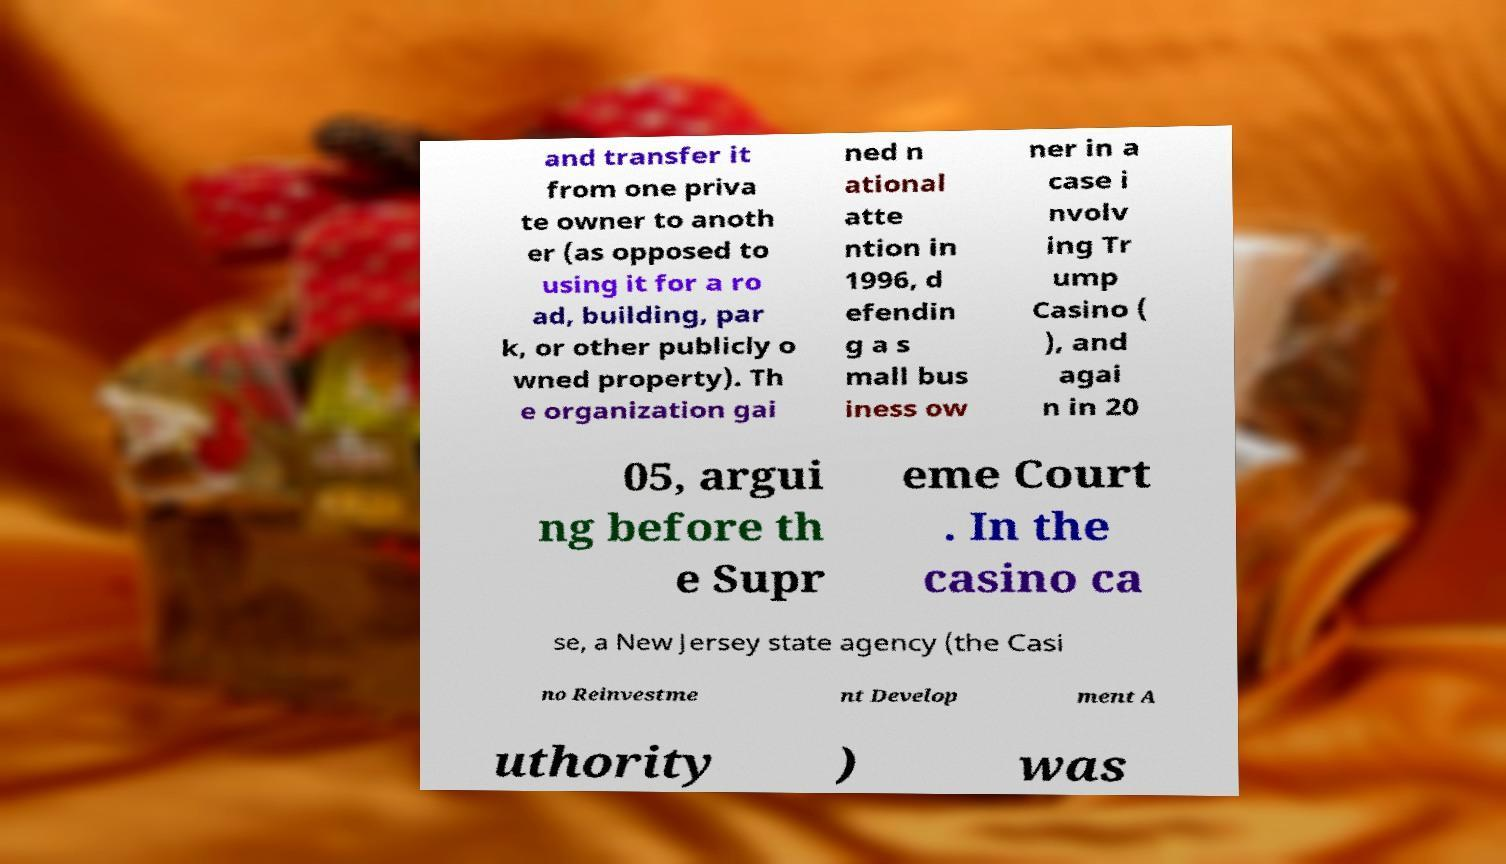Please read and relay the text visible in this image. What does it say? and transfer it from one priva te owner to anoth er (as opposed to using it for a ro ad, building, par k, or other publicly o wned property). Th e organization gai ned n ational atte ntion in 1996, d efendin g a s mall bus iness ow ner in a case i nvolv ing Tr ump Casino ( ), and agai n in 20 05, argui ng before th e Supr eme Court . In the casino ca se, a New Jersey state agency (the Casi no Reinvestme nt Develop ment A uthority ) was 